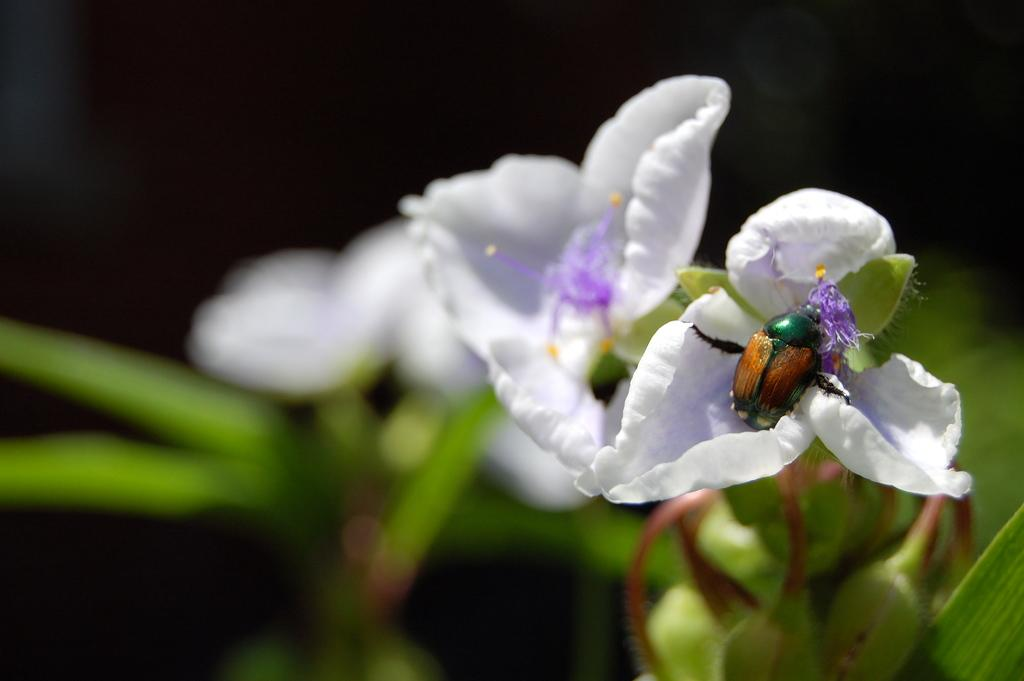What type of plants can be seen in the image? There are plants with flowers in the image. Can you describe any living organisms present on the plants? Yes, there is an insect on one of the flowers. What type of drug is being sold in the image? There is no drug being sold in the image; it features plants with flowers and an insect. What type of yard is visible in the image? The image does not show a yard; it only shows plants with flowers and an insect. 